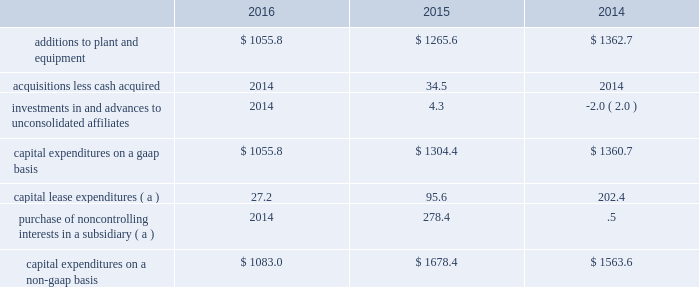Investing activities for the year ended 30 september 2016 , cash used for investing activities was $ 972.0 , driven by capital expenditures for plant and equipment of $ 1055.8 .
Proceeds from the sale of assets and investments of $ 85.5 was primarily driven by the receipt of $ 30.0 for our rights to a corporate aircraft that was under construction , $ 15.9 for the sale of our 20% ( 20 % ) equity investment in daido air products electronics , inc. , and $ 14.9 for the sale of a wholly owned subsidiary located in wuhu , china .
For the year ended 30 september 2015 , cash used for investing activities was $ 1250.5 , primarily capital expenditures for plant and equipment .
On 30 december 2014 , we acquired our partner 2019s equity ownership interest in a liquefied atmospheric industrial gases production joint venture in north america which increased our ownership from 50% ( 50 % ) to 100% ( 100 % ) .
Refer to note 6 , business combination , to the consolidated financial statements for additional information .
For the year ended 30 september 2014 , cash used for investing activities was $ 1316.5 , primarily capital expenditures for plant and equipment .
Refer to the capital expenditures section below for additional detail .
Capital expenditures capital expenditures are detailed in the table: .
( a ) we utilize a non-gaap measure in the computation of capital expenditures and include spending associated with facilities accounted for as capital leases and purchases of noncontrolling interests .
Certain contracts associated with facilities that are built to provide product to a specific customer are required to be accounted for as leases , and such spending is reflected as a use of cash within cash provided by operating activities , if the arrangement qualifies as a capital lease .
Additionally , the purchase of subsidiary shares from noncontrolling interests is accounted for as a financing activity in the statement of cash flows .
The presentation of this non-gaap measure is intended to enhance the usefulness of information by providing a measure that our management uses internally to evaluate and manage our expenditures .
Capital expenditures on a gaap basis in 2016 totaled $ 1055.8 , compared to $ 1265.6 in 2015 .
The decrease of $ 209.8 was primarily due to the completion of major projects in 2016 and 2015 .
Additions to plant and equipment also included support capital of a routine , ongoing nature , including expenditures for distribution equipment and facility improvements .
Spending in 2016 and 2015 included plant and equipment constructed to provide oxygen for coal gasification in china , hydrogen to the global market , oxygen to the steel industry , nitrogen to the electronic semiconductor industry , and capacity expansion for the materials technologies segment .
Capital expenditures on a non-gaap basis in 2016 totaled $ 1083.0 compared to $ 1678.4 in 2015 .
The decrease of $ 595.4 was primarily due to the prior year purchase of the 30.5% ( 30.5 % ) equity interest in our indura s.a .
Subsidiary from the largest minority shareholder for $ 277.9 .
Refer to note 21 , noncontrolling interests , to the consolidated financial statements for additional details .
Additionally , capital lease expenditures of $ 27.2 , decreased by $ 68.4 , reflecting lower project spending .
On 19 april 2015 , a joint venture between air products and acwa holding entered into a 20-year oxygen and nitrogen supply agreement to supply saudi aramco 2019s oil refinery and power plant being built in jazan , saudi arabia .
Air products owns 25% ( 25 % ) of the joint venture .
During 2016 and 2015 , we recorded noncash transactions which resulted in an increase of $ 26.9 and $ 67.5 , respectively , to our investment in net assets of and advances to equity affiliates for our obligation to invest in the joint venture .
These noncash transactions have been excluded from the consolidated statements of cash flows .
In total , we expect to invest approximately $ 100 in this joint venture .
Air products has also entered into a sale of equipment contract with the joint venture to engineer , procure , and construct the industrial gas facilities that will supply the gases to saudi aramco. .
Considering the capital expenditures on a gaap basis , what was the percentual decrease observed in 2016 in comparison with 2015? 
Rationale: it is the final value of capital expenditures minus the initial value , then divided by the initial one and turned into a percentage to represent the variation .
Computations: ((1055.8 - 1265.6) / 1265.6)
Answer: -0.16577. 